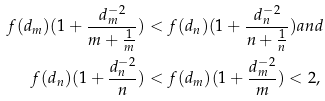<formula> <loc_0><loc_0><loc_500><loc_500>f ( d _ { m } ) ( 1 + \frac { d _ { m } ^ { - 2 } } { m + \frac { 1 } { m } } ) & < f ( d _ { n } ) ( 1 + \frac { d _ { n } ^ { - 2 } } { n + \frac { 1 } { n } } ) a n d \\ f ( d _ { n } ) ( 1 + \frac { d _ { n } ^ { - 2 } } { n } ) & < f ( d _ { m } ) ( 1 + \frac { d _ { m } ^ { - 2 } } { m } ) < 2 ,</formula> 